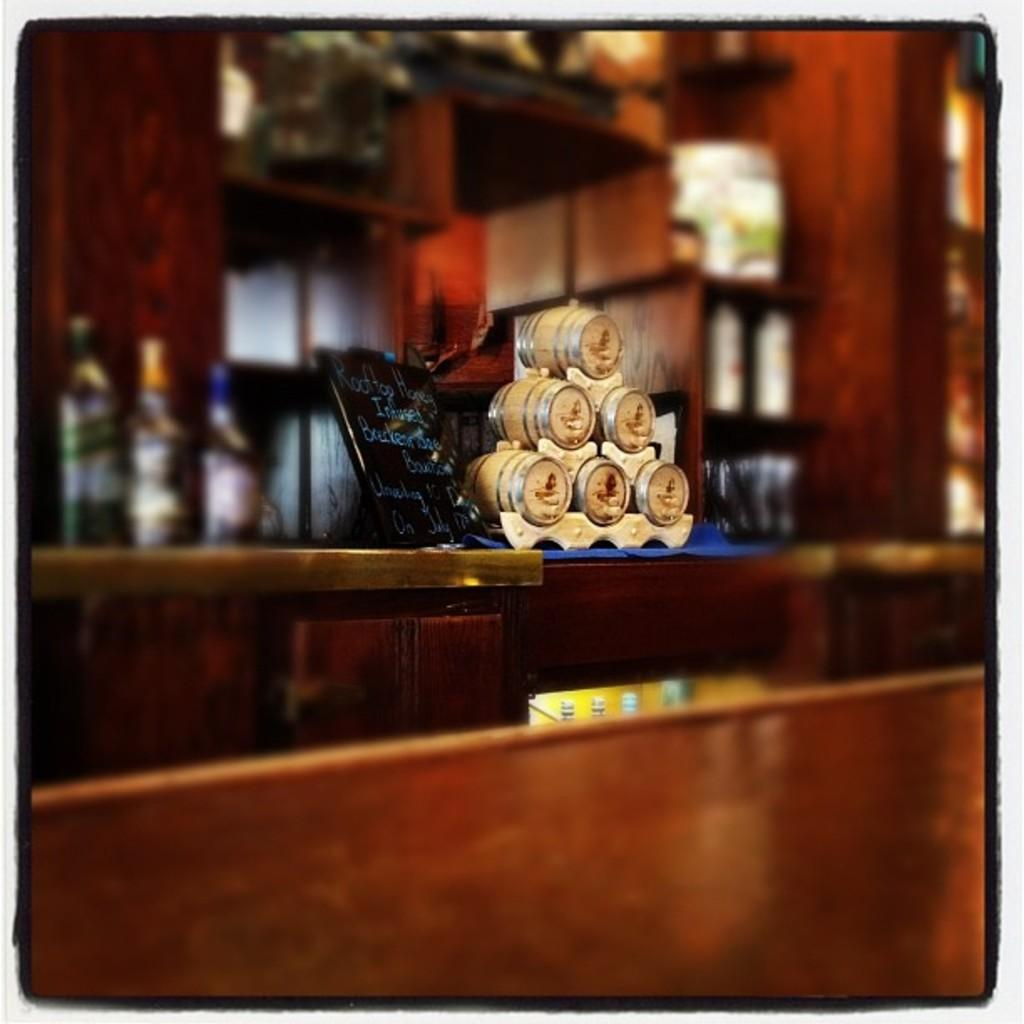What piece of furniture is present in the image? A: There is a table in the image. What is placed on top of the table? There is a photo frame and bottles on the table. What can be seen in the background of the image? There are cupboards in the background of the image. What type of guitar is being played by the army during the war in the image? There is no guitar, army, or war present in the image. 